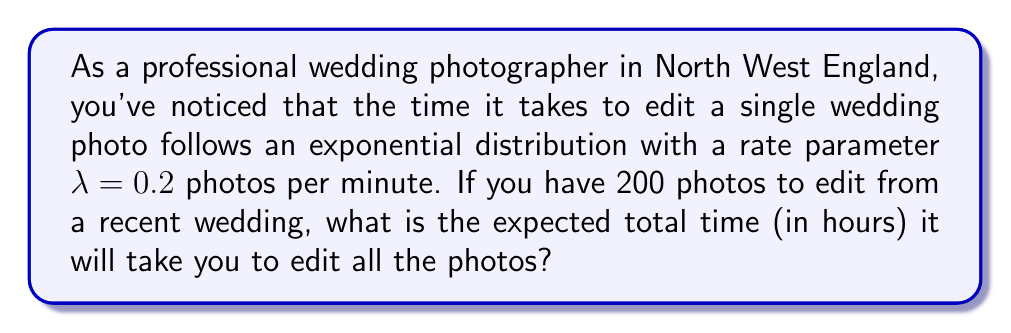What is the answer to this math problem? Let's approach this step-by-step:

1) The exponential distribution has a mean (average) of $\frac{1}{\lambda}$.

2) In this case, $\lambda = 0.2$ photos per minute. So the average time to edit one photo is:

   $$\frac{1}{\lambda} = \frac{1}{0.2} = 5 \text{ minutes per photo}$$

3) We need to edit 200 photos. The total expected time is:

   $$200 \times 5 = 1000 \text{ minutes}$$

4) To convert this to hours, we divide by 60:

   $$\frac{1000}{60} = \frac{50}{3} \approx 16.67 \text{ hours}$$

Therefore, the expected total time to edit all 200 photos is approximately 16.67 hours.
Answer: $\frac{50}{3}$ hours 